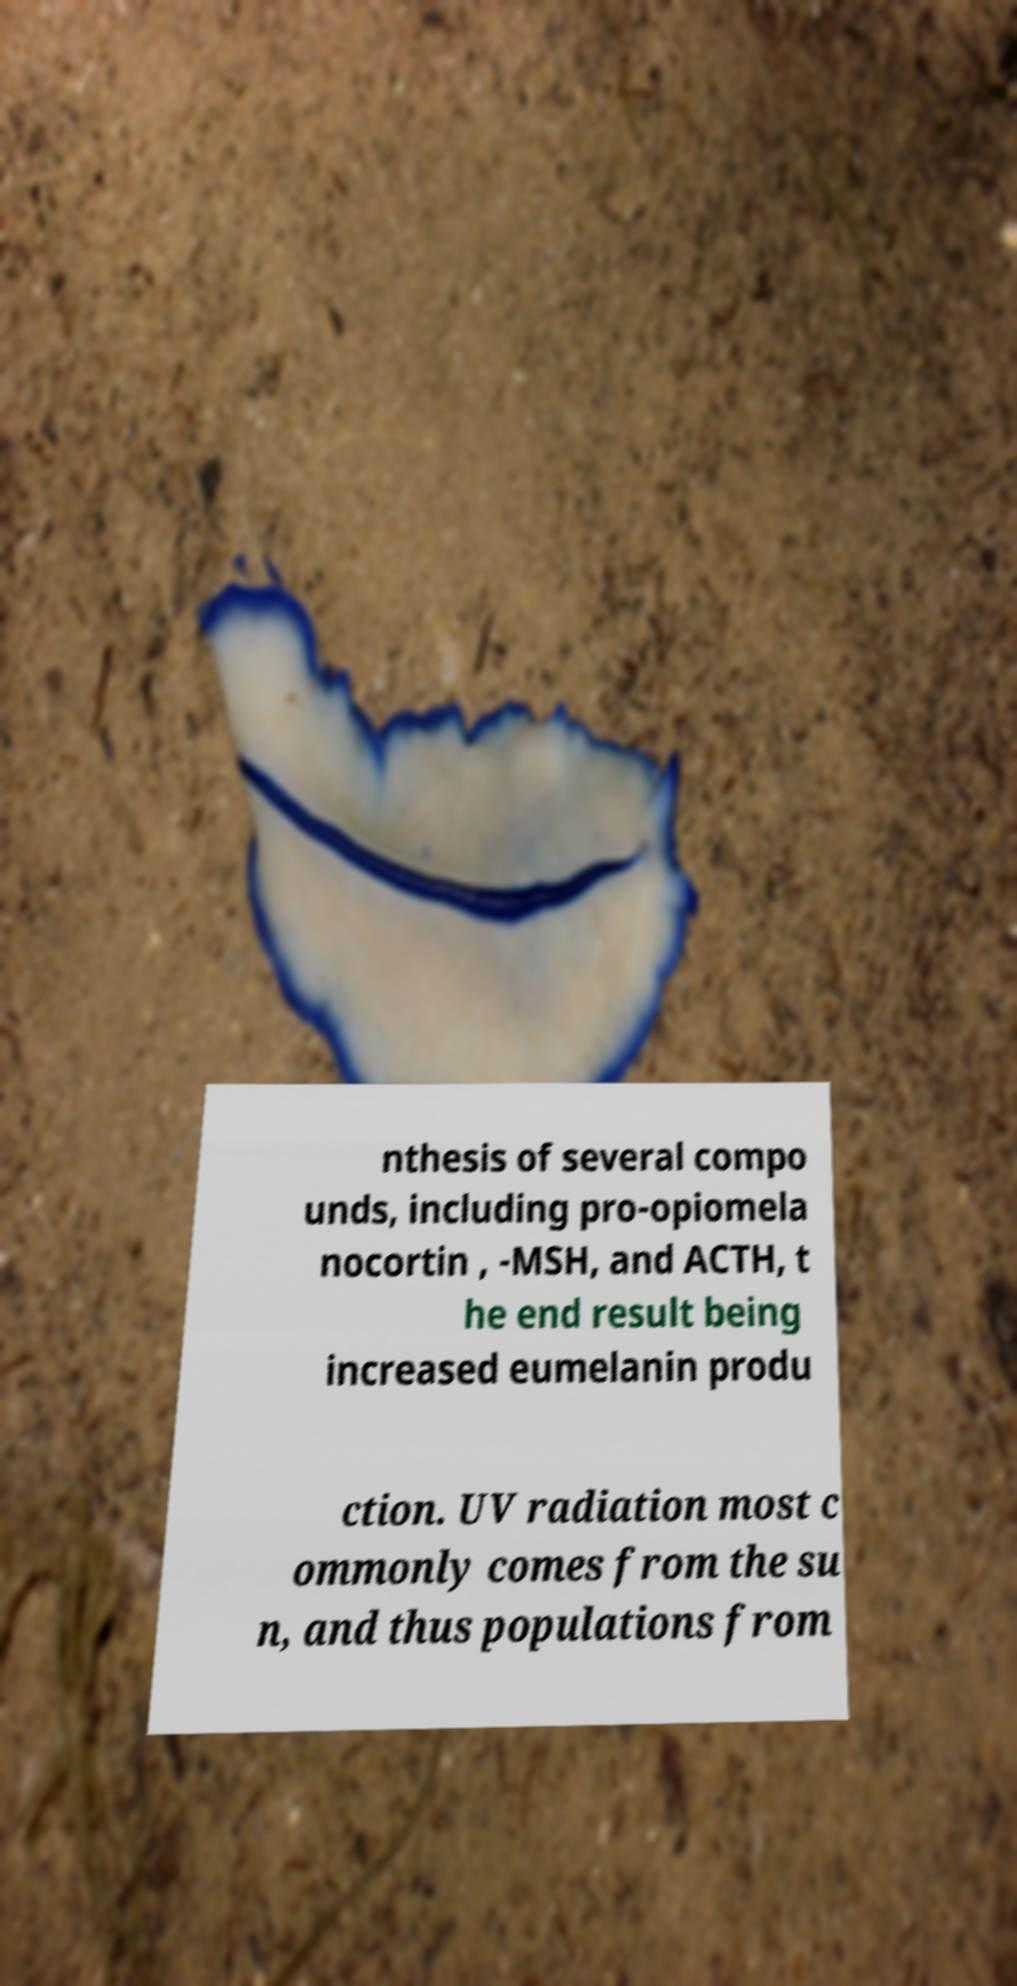Can you read and provide the text displayed in the image?This photo seems to have some interesting text. Can you extract and type it out for me? nthesis of several compo unds, including pro-opiomela nocortin , -MSH, and ACTH, t he end result being increased eumelanin produ ction. UV radiation most c ommonly comes from the su n, and thus populations from 